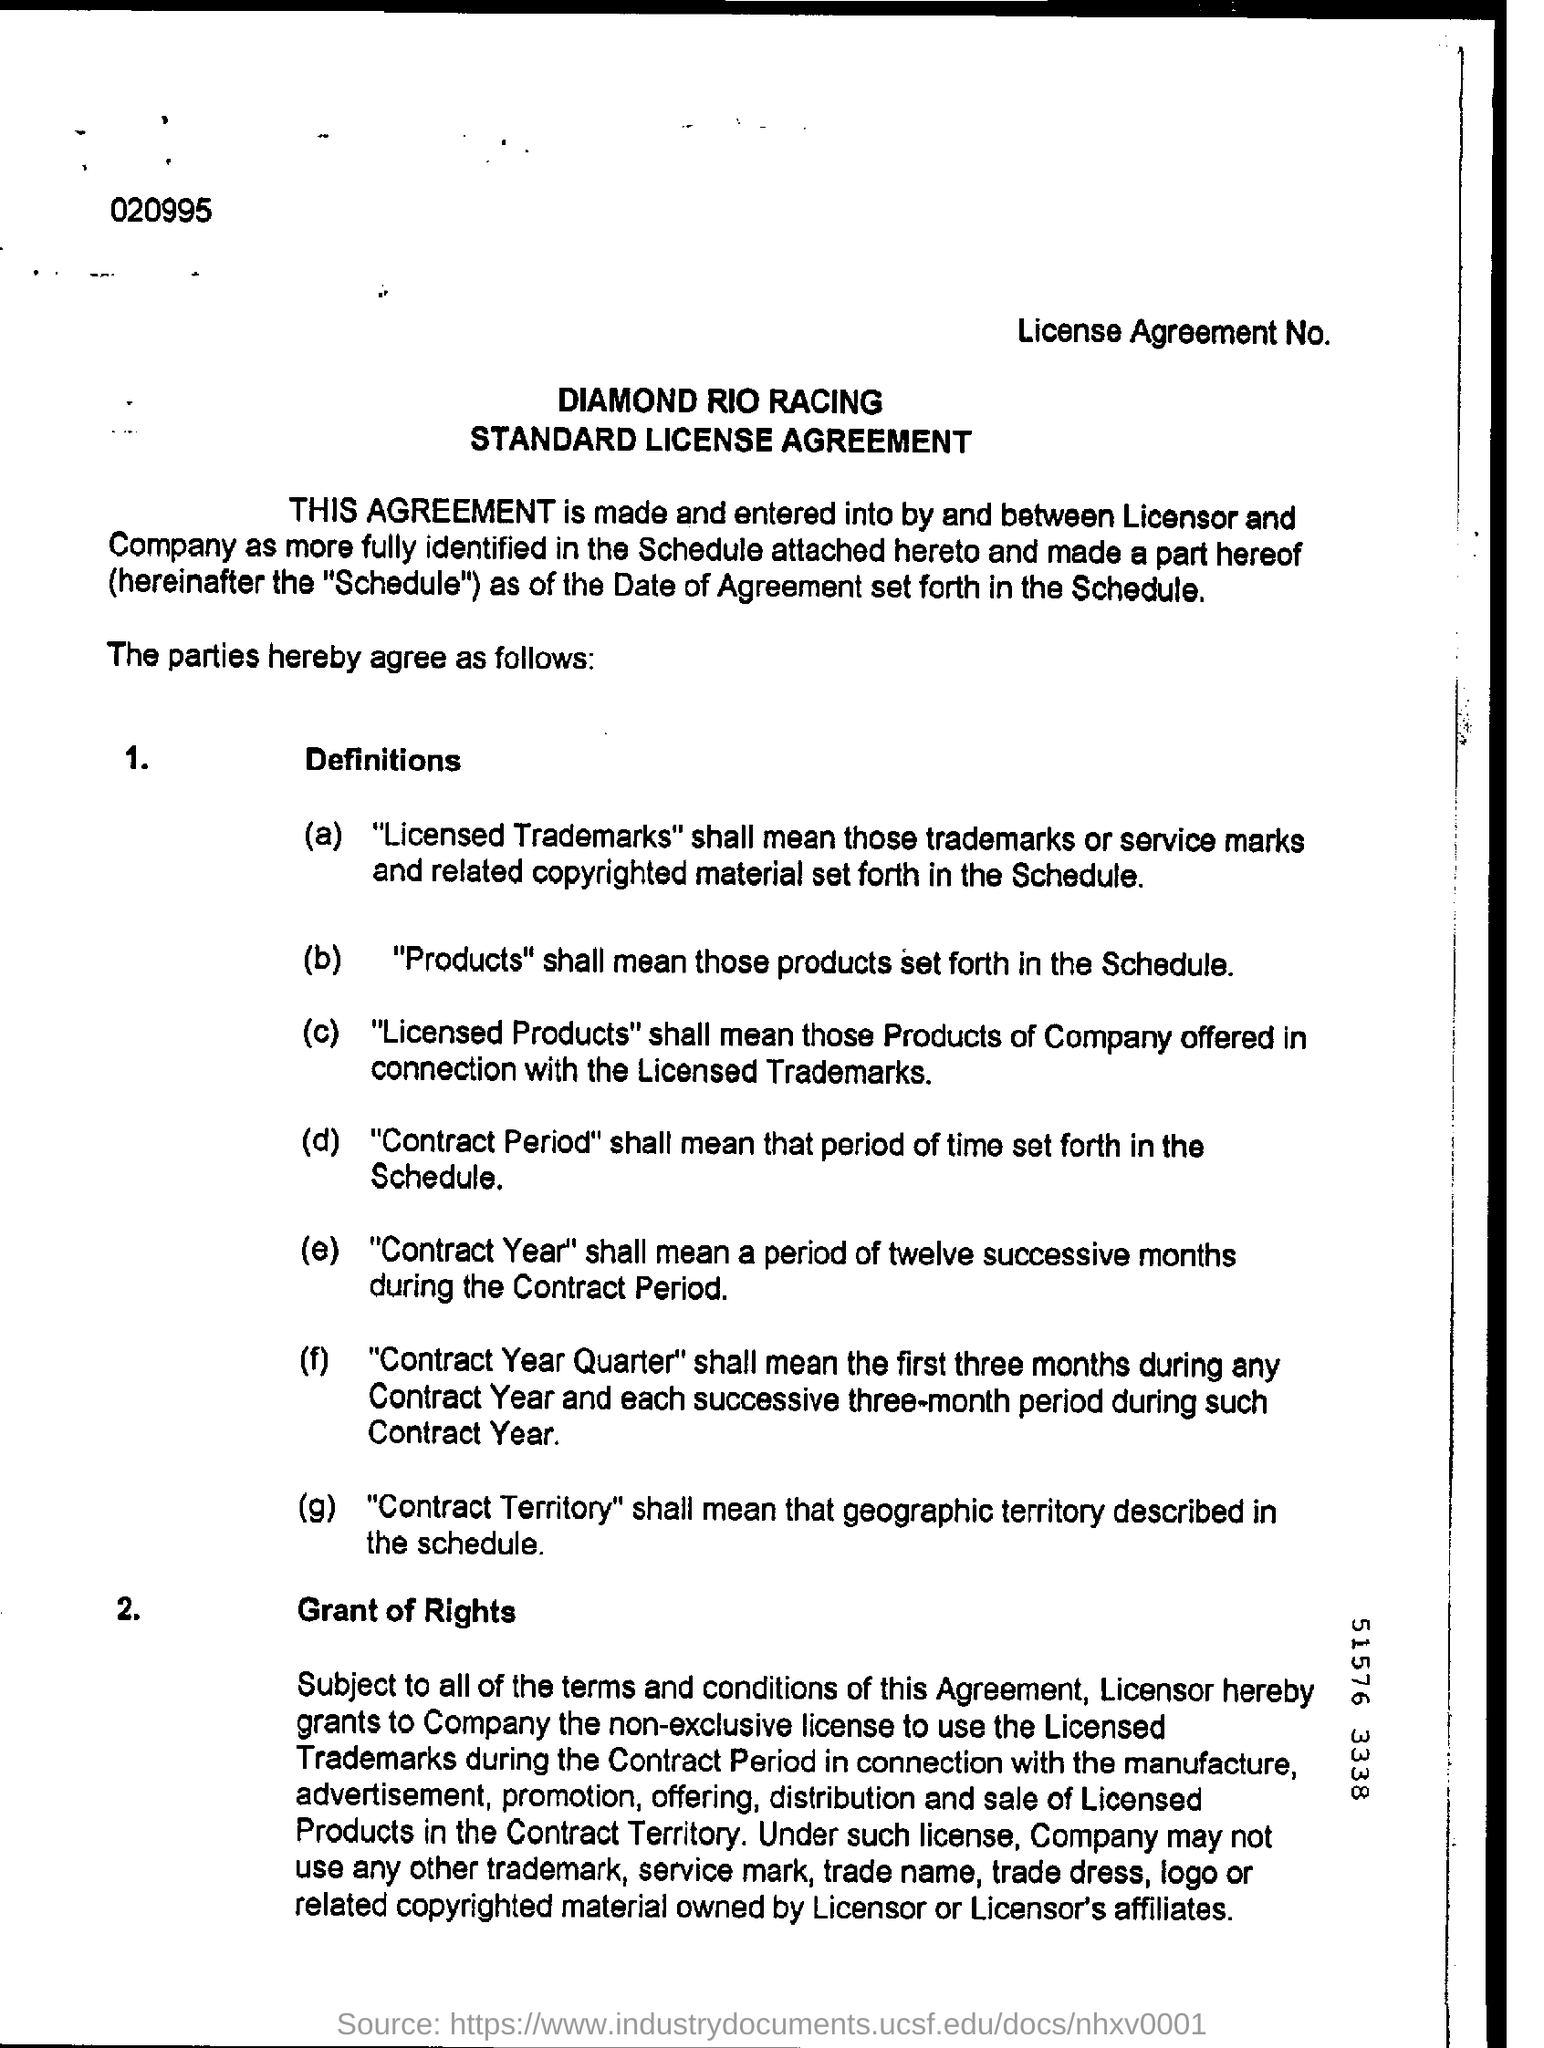What is the second agreement about?
Give a very brief answer. Grant of Rights. Who are the two parties between which the license is made?
Provide a succinct answer. Licensor and Company. What is the number at the top left?
Make the answer very short. 020995. 